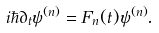<formula> <loc_0><loc_0><loc_500><loc_500>i \hbar { \partial } _ { t } \psi ^ { ( n ) } = F _ { n } ( t ) \psi ^ { ( n ) } .</formula> 